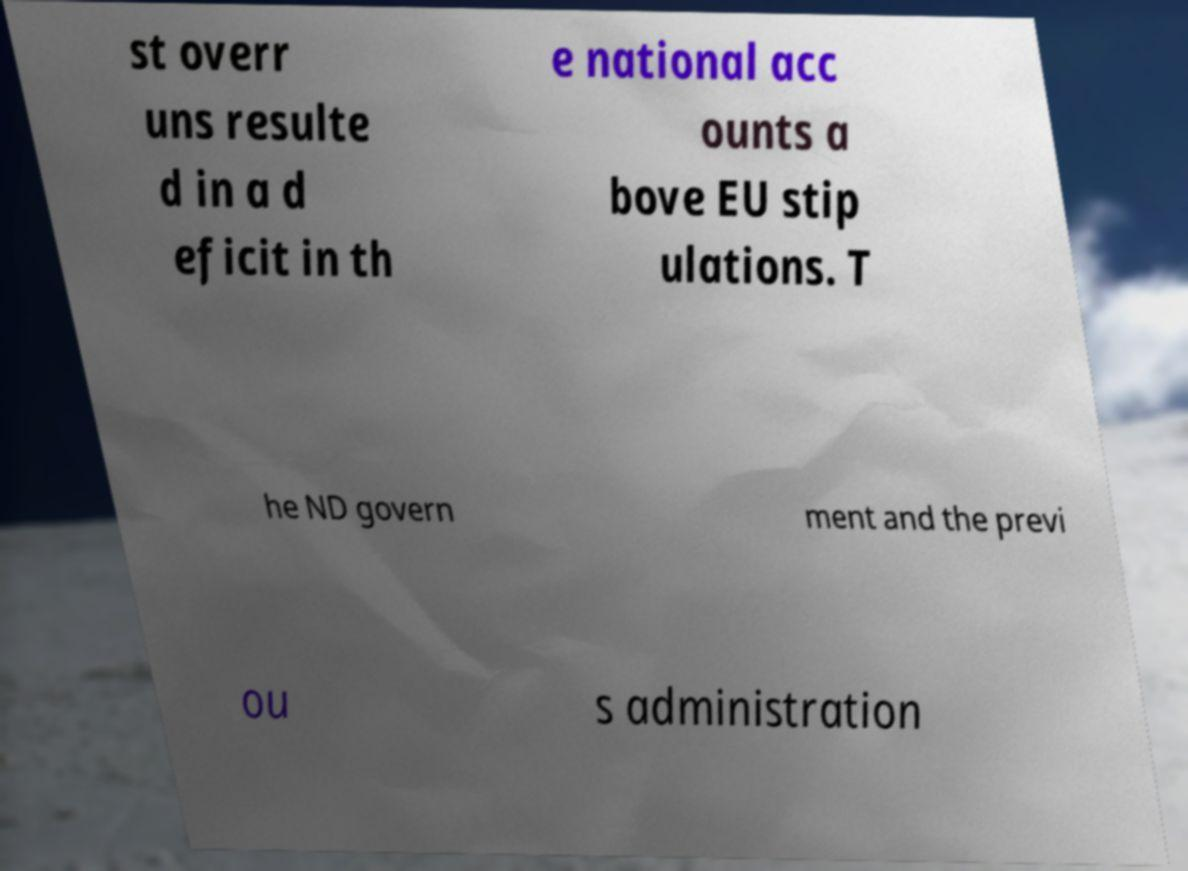Could you extract and type out the text from this image? st overr uns resulte d in a d eficit in th e national acc ounts a bove EU stip ulations. T he ND govern ment and the previ ou s administration 